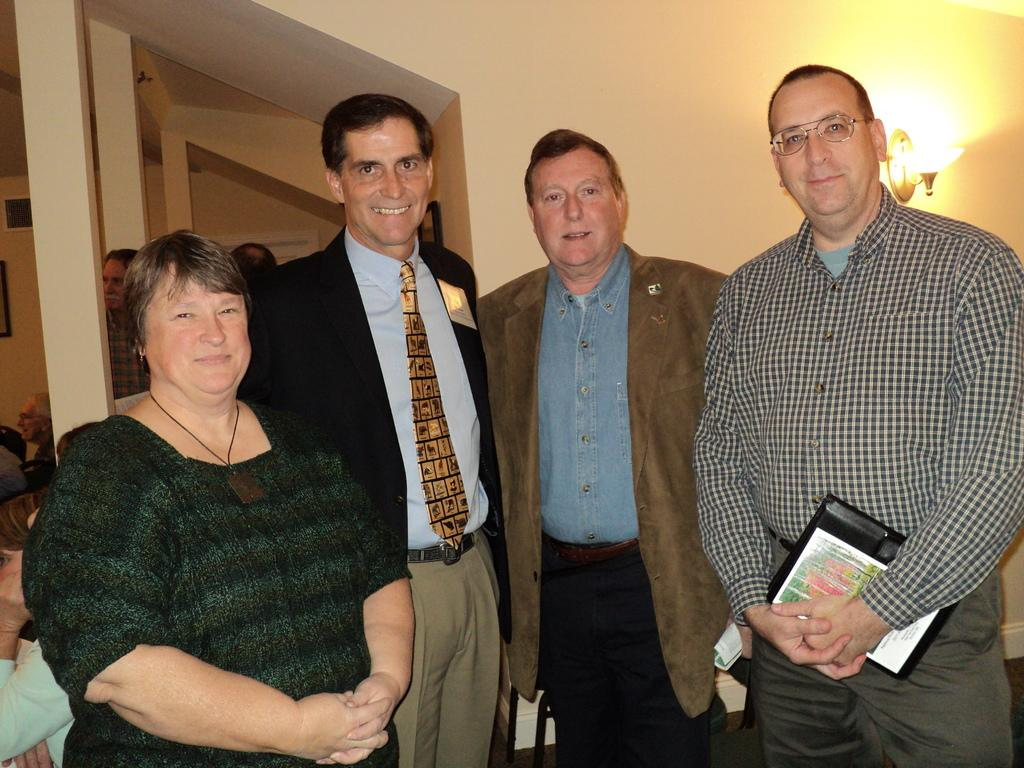How many people can be seen in the image? There are many persons standing on the floor in the image. What can be seen in the background of the image? There are pillars, people, light, and a wall visible in the background of the image. What type of mist can be seen in the harbor in the image? There is no mist or harbor present in the image. What date is marked on the calendar in the image? There is no calendar present in the image. 